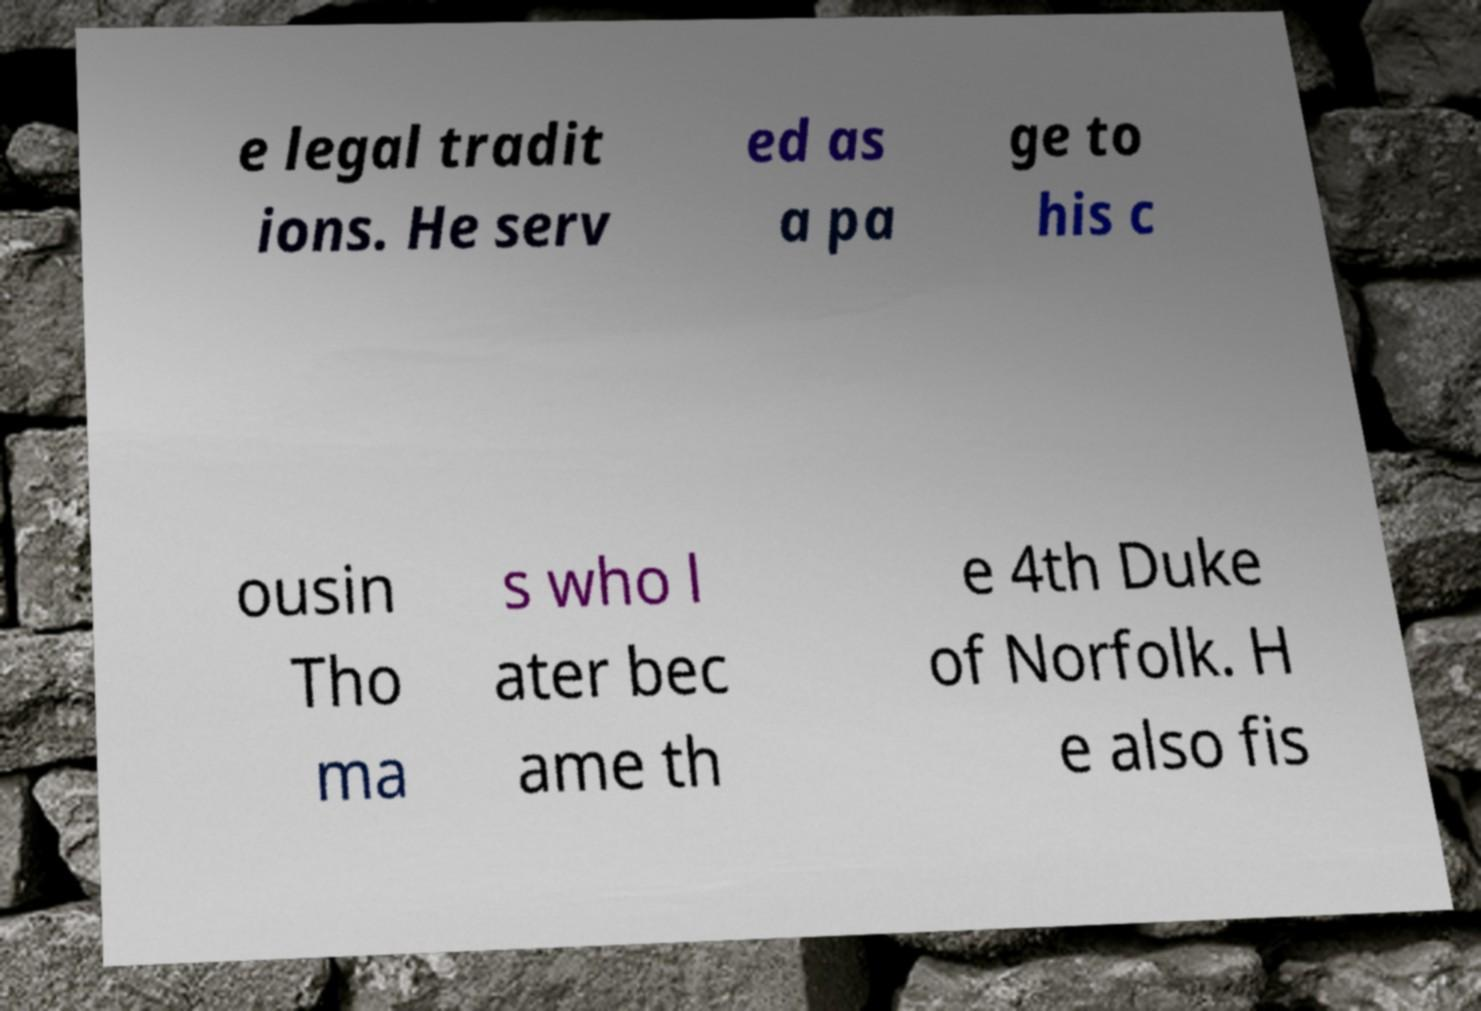For documentation purposes, I need the text within this image transcribed. Could you provide that? e legal tradit ions. He serv ed as a pa ge to his c ousin Tho ma s who l ater bec ame th e 4th Duke of Norfolk. H e also fis 